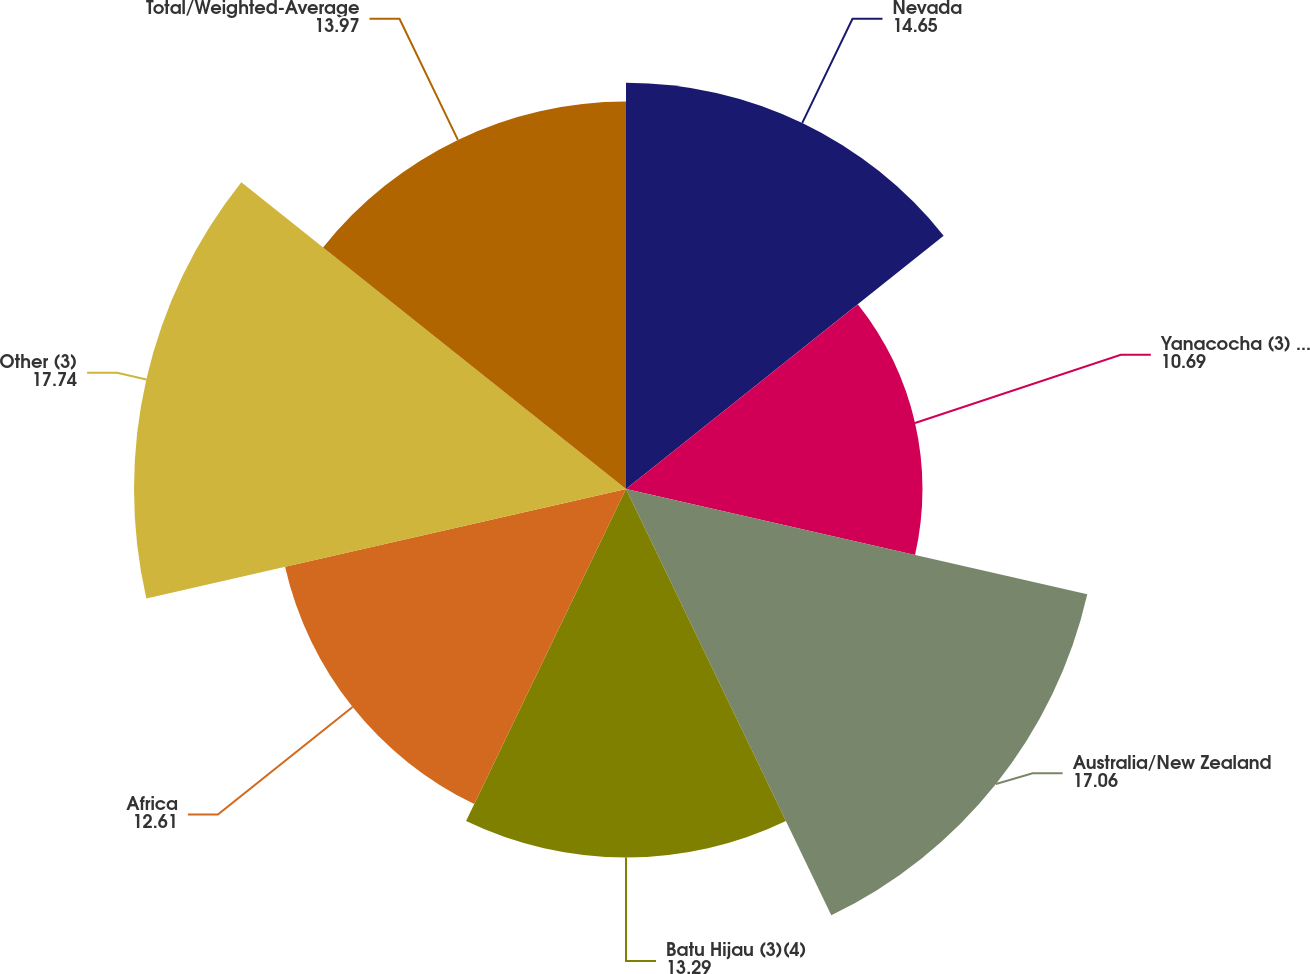<chart> <loc_0><loc_0><loc_500><loc_500><pie_chart><fcel>Nevada<fcel>Yanacocha (3) (5135 owned)<fcel>Australia/New Zealand<fcel>Batu Hijau (3)(4)<fcel>Africa<fcel>Other (3)<fcel>Total/Weighted-Average<nl><fcel>14.65%<fcel>10.69%<fcel>17.06%<fcel>13.29%<fcel>12.61%<fcel>17.74%<fcel>13.97%<nl></chart> 